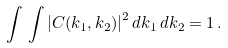<formula> <loc_0><loc_0><loc_500><loc_500>\int \, \int \left | C ( k _ { 1 } , k _ { 2 } ) \right | ^ { 2 } d k _ { 1 } \, d k _ { 2 } = 1 \, .</formula> 